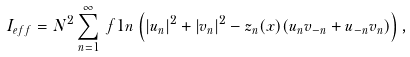<formula> <loc_0><loc_0><loc_500><loc_500>I _ { e f f } & = N ^ { 2 } \sum _ { n = 1 } ^ { \infty } \ f { 1 } { n } \left ( | u _ { n } | ^ { 2 } + | v _ { n } | ^ { 2 } - z _ { n } ( x ) ( u _ { n } v _ { - n } + u _ { - n } v _ { n } ) \right ) ,</formula> 